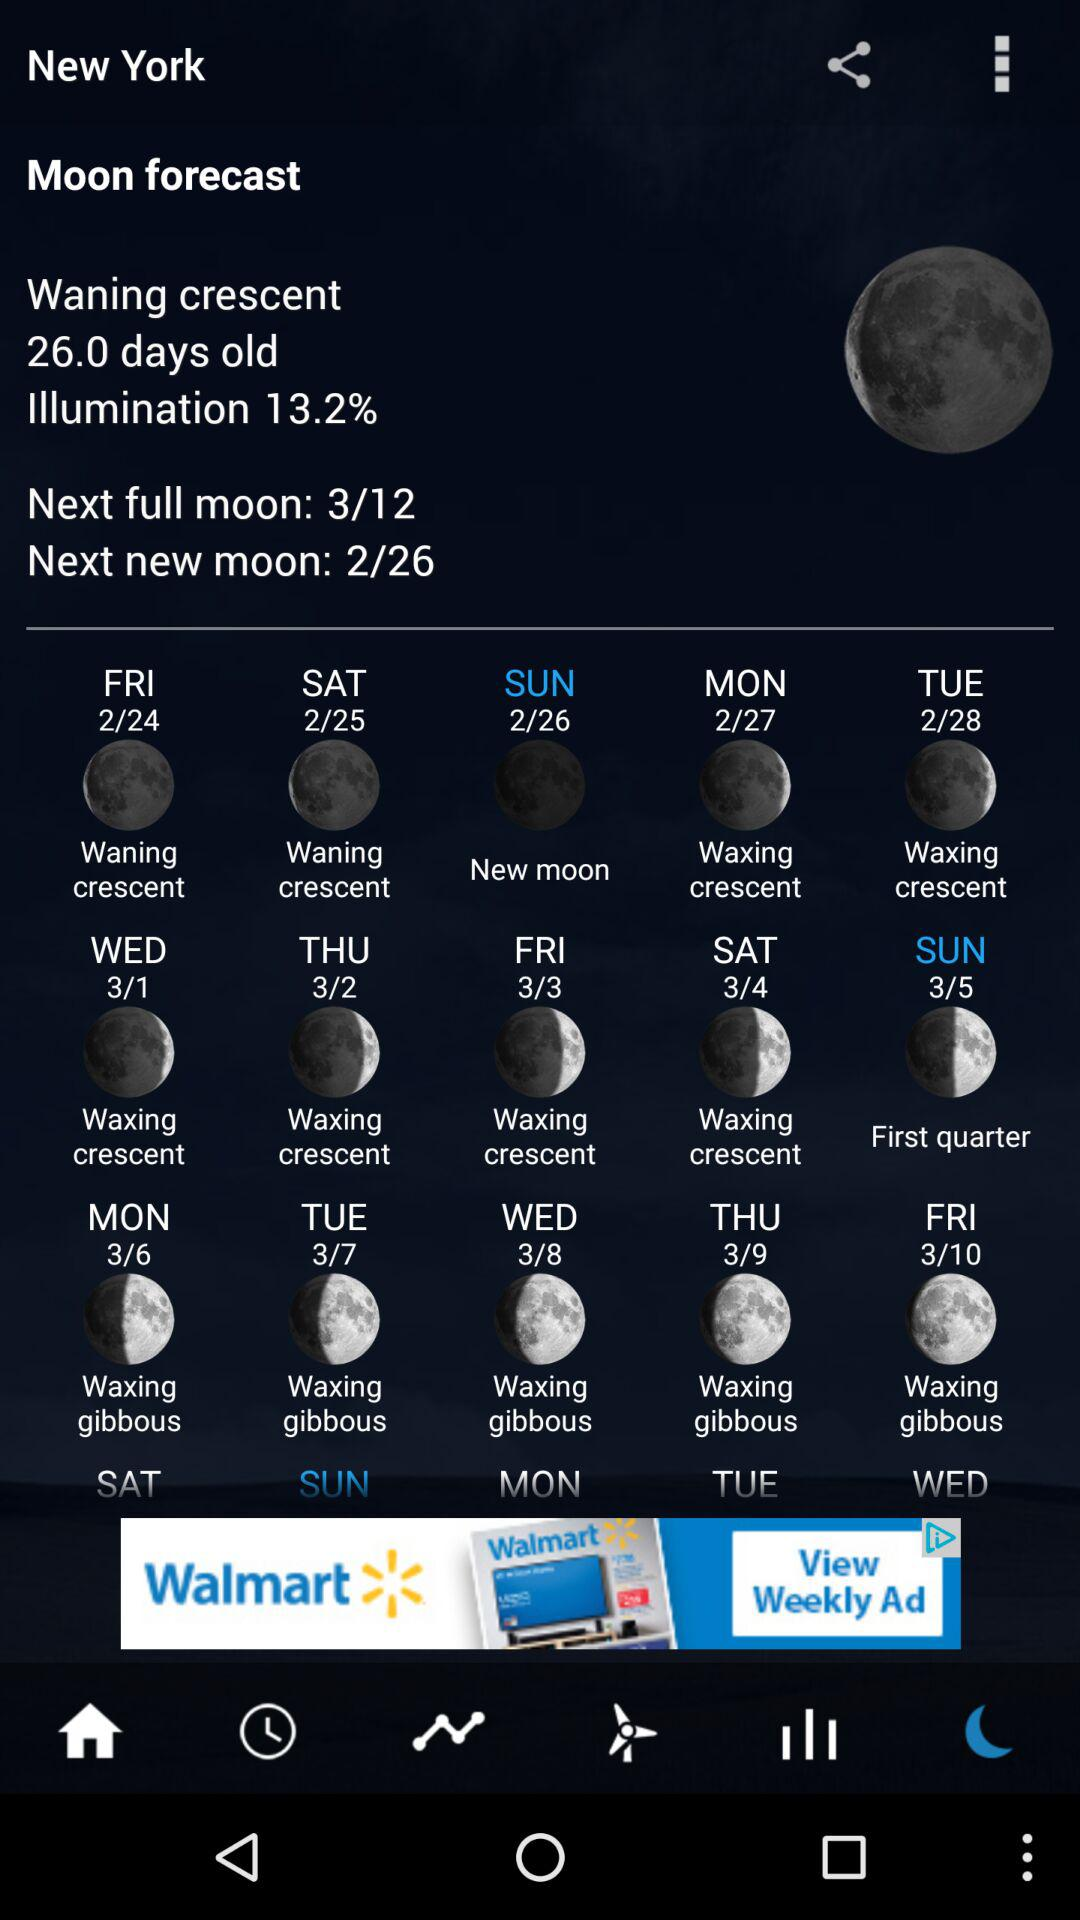What is the percentage of illumination?
Answer the question using a single word or phrase. Illumination is 13.2%. 